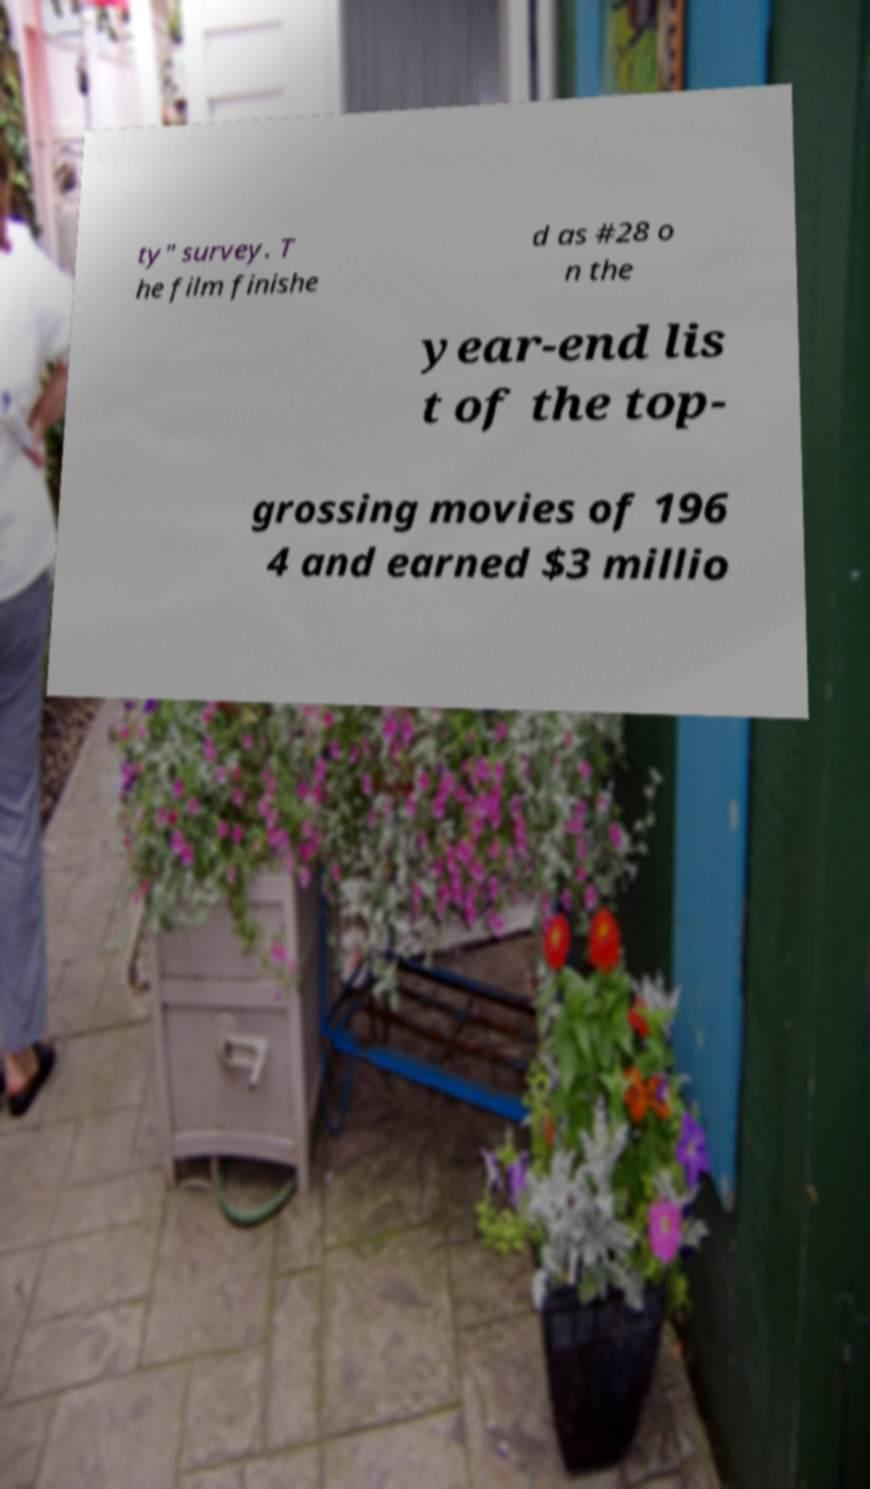I need the written content from this picture converted into text. Can you do that? ty" survey. T he film finishe d as #28 o n the year-end lis t of the top- grossing movies of 196 4 and earned $3 millio 